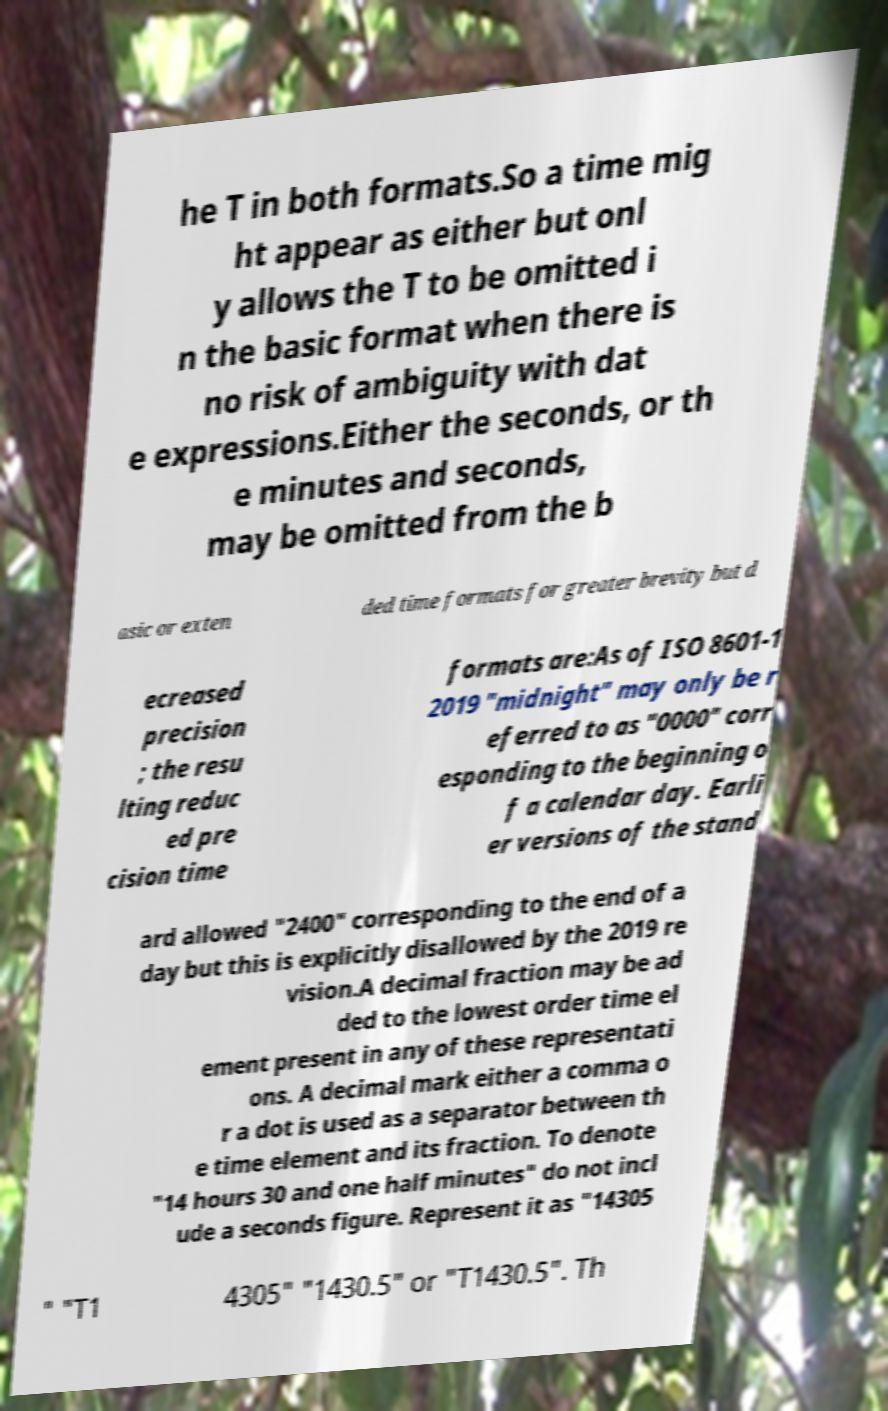I need the written content from this picture converted into text. Can you do that? he T in both formats.So a time mig ht appear as either but onl y allows the T to be omitted i n the basic format when there is no risk of ambiguity with dat e expressions.Either the seconds, or th e minutes and seconds, may be omitted from the b asic or exten ded time formats for greater brevity but d ecreased precision ; the resu lting reduc ed pre cision time formats are:As of ISO 8601-1 2019 "midnight" may only be r eferred to as "0000" corr esponding to the beginning o f a calendar day. Earli er versions of the stand ard allowed "2400" corresponding to the end of a day but this is explicitly disallowed by the 2019 re vision.A decimal fraction may be ad ded to the lowest order time el ement present in any of these representati ons. A decimal mark either a comma o r a dot is used as a separator between th e time element and its fraction. To denote "14 hours 30 and one half minutes" do not incl ude a seconds figure. Represent it as "14305 " "T1 4305" "1430.5" or "T1430.5". Th 